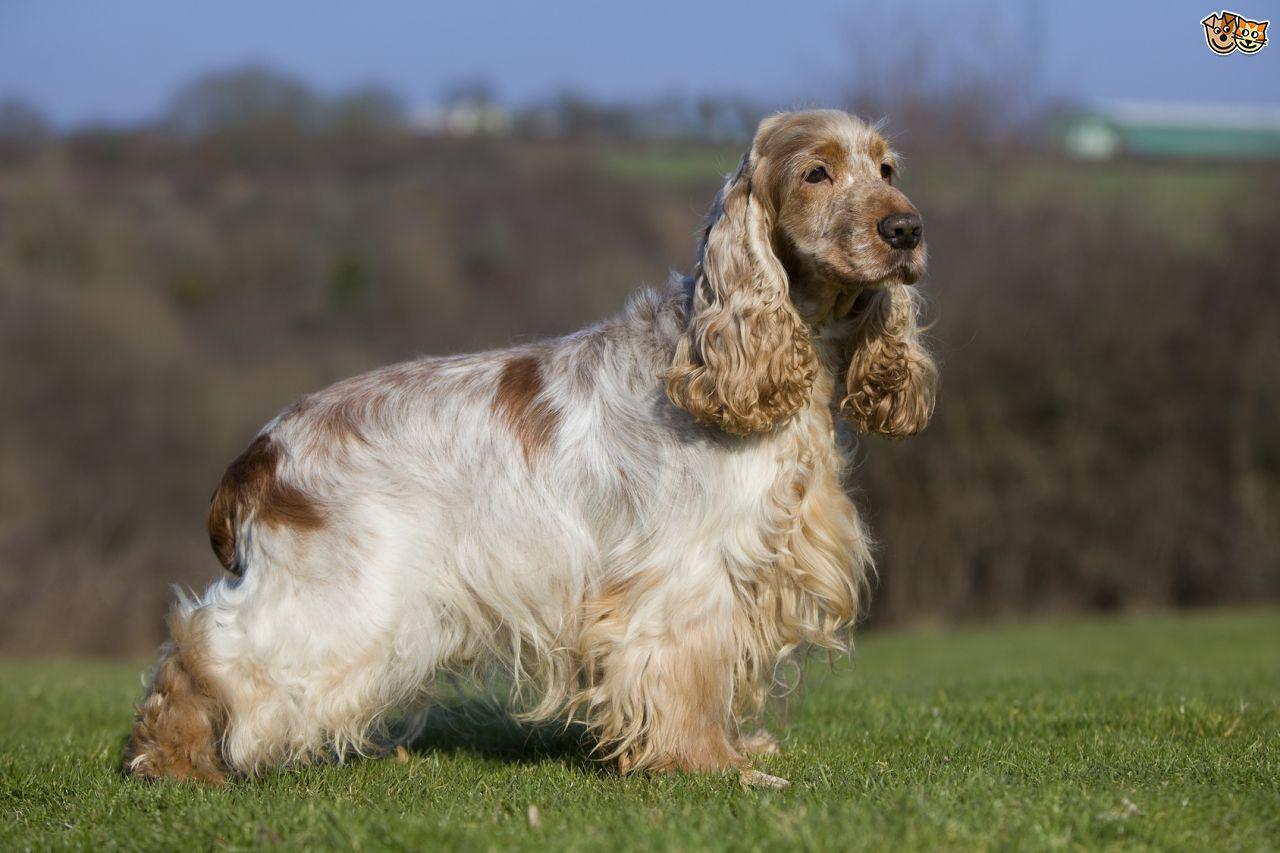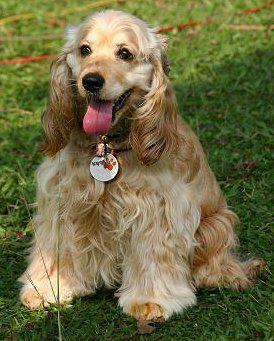The first image is the image on the left, the second image is the image on the right. Evaluate the accuracy of this statement regarding the images: "The dogs on the left image have plain white background.". Is it true? Answer yes or no. No. 